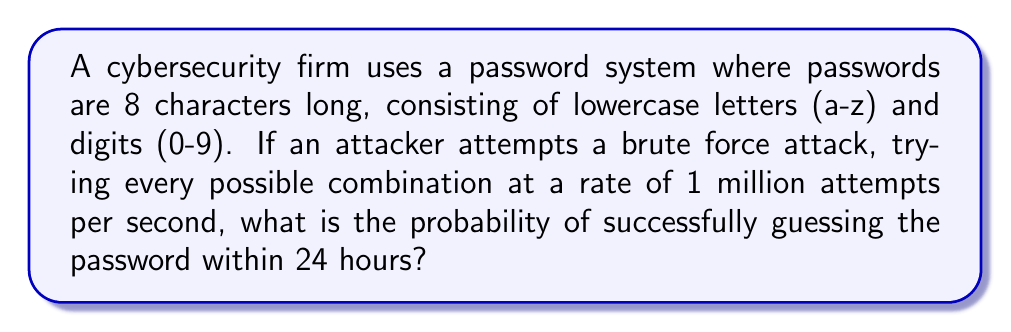Help me with this question. Let's approach this step-by-step:

1) First, calculate the total number of possible passwords:
   - Characters available: 26 letters + 10 digits = 36 characters
   - Password length: 8 characters
   - Total combinations: $36^8 = 2,821,109,907,456$

2) Calculate the number of attempts possible in 24 hours:
   - Attempts per second: 1,000,000
   - Seconds in 24 hours: $24 * 60 * 60 = 86,400$
   - Total attempts in 24 hours: $1,000,000 * 86,400 = 86,400,000,000$

3) Calculate the probability:
   $$P(\text{success}) = \frac{\text{Number of attempts}}{\text{Total possible combinations}}$$
   
   $$P(\text{success}) = \frac{86,400,000,000}{2,821,109,907,456}$$
   
   $$P(\text{success}) \approx 0.0306$$

4) Convert to percentage:
   $0.0306 * 100\% = 3.06\%$

Therefore, the probability of successfully guessing the password within 24 hours is approximately 3.06%.
Answer: $3.06\%$ 